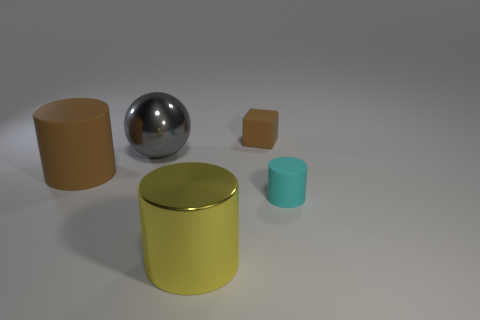Add 4 small gray blocks. How many objects exist? 9 Subtract all yellow cylinders. How many cylinders are left? 2 Subtract all cyan cylinders. How many cylinders are left? 2 Subtract all spheres. How many objects are left? 4 Subtract 3 cylinders. How many cylinders are left? 0 Subtract all purple balls. How many gray cylinders are left? 0 Subtract all purple balls. Subtract all tiny rubber cylinders. How many objects are left? 4 Add 4 small things. How many small things are left? 6 Add 1 tiny yellow objects. How many tiny yellow objects exist? 1 Subtract 0 purple cylinders. How many objects are left? 5 